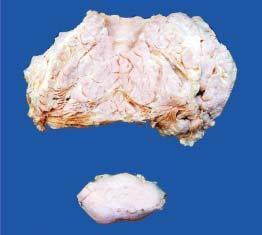do collections of histiocytes show circumscribed?
Answer the question using a single word or phrase. No 